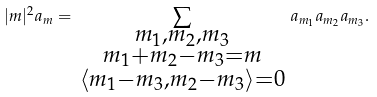Convert formula to latex. <formula><loc_0><loc_0><loc_500><loc_500>| m | ^ { 2 } a _ { m } = \, \sum _ { \substack { m _ { 1 } , m _ { 2 } , m _ { 3 } \\ m _ { 1 } + m _ { 2 } - m _ { 3 } = m \\ \langle m _ { 1 } - m _ { 3 } , m _ { 2 } - m _ { 3 } \rangle = 0 } } \, a _ { m _ { 1 } } a _ { m _ { 2 } } a _ { m _ { 3 } } .</formula> 